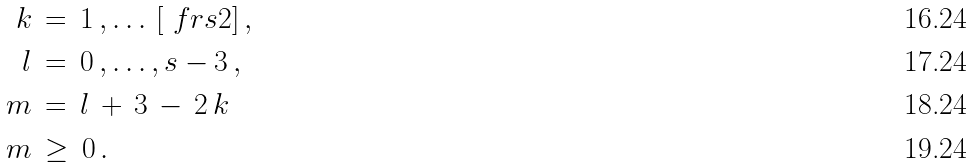<formula> <loc_0><loc_0><loc_500><loc_500>k \, & = \, 1 \, , \dots \, [ \ f r { s } { 2 } ] \, , \\ l \, & = \, 0 \, , \dots , s - 3 \, , \\ m \, & = \, l \, + \, 3 \, - \, 2 \, k \, \\ m \, & \geq \, 0 \, .</formula> 